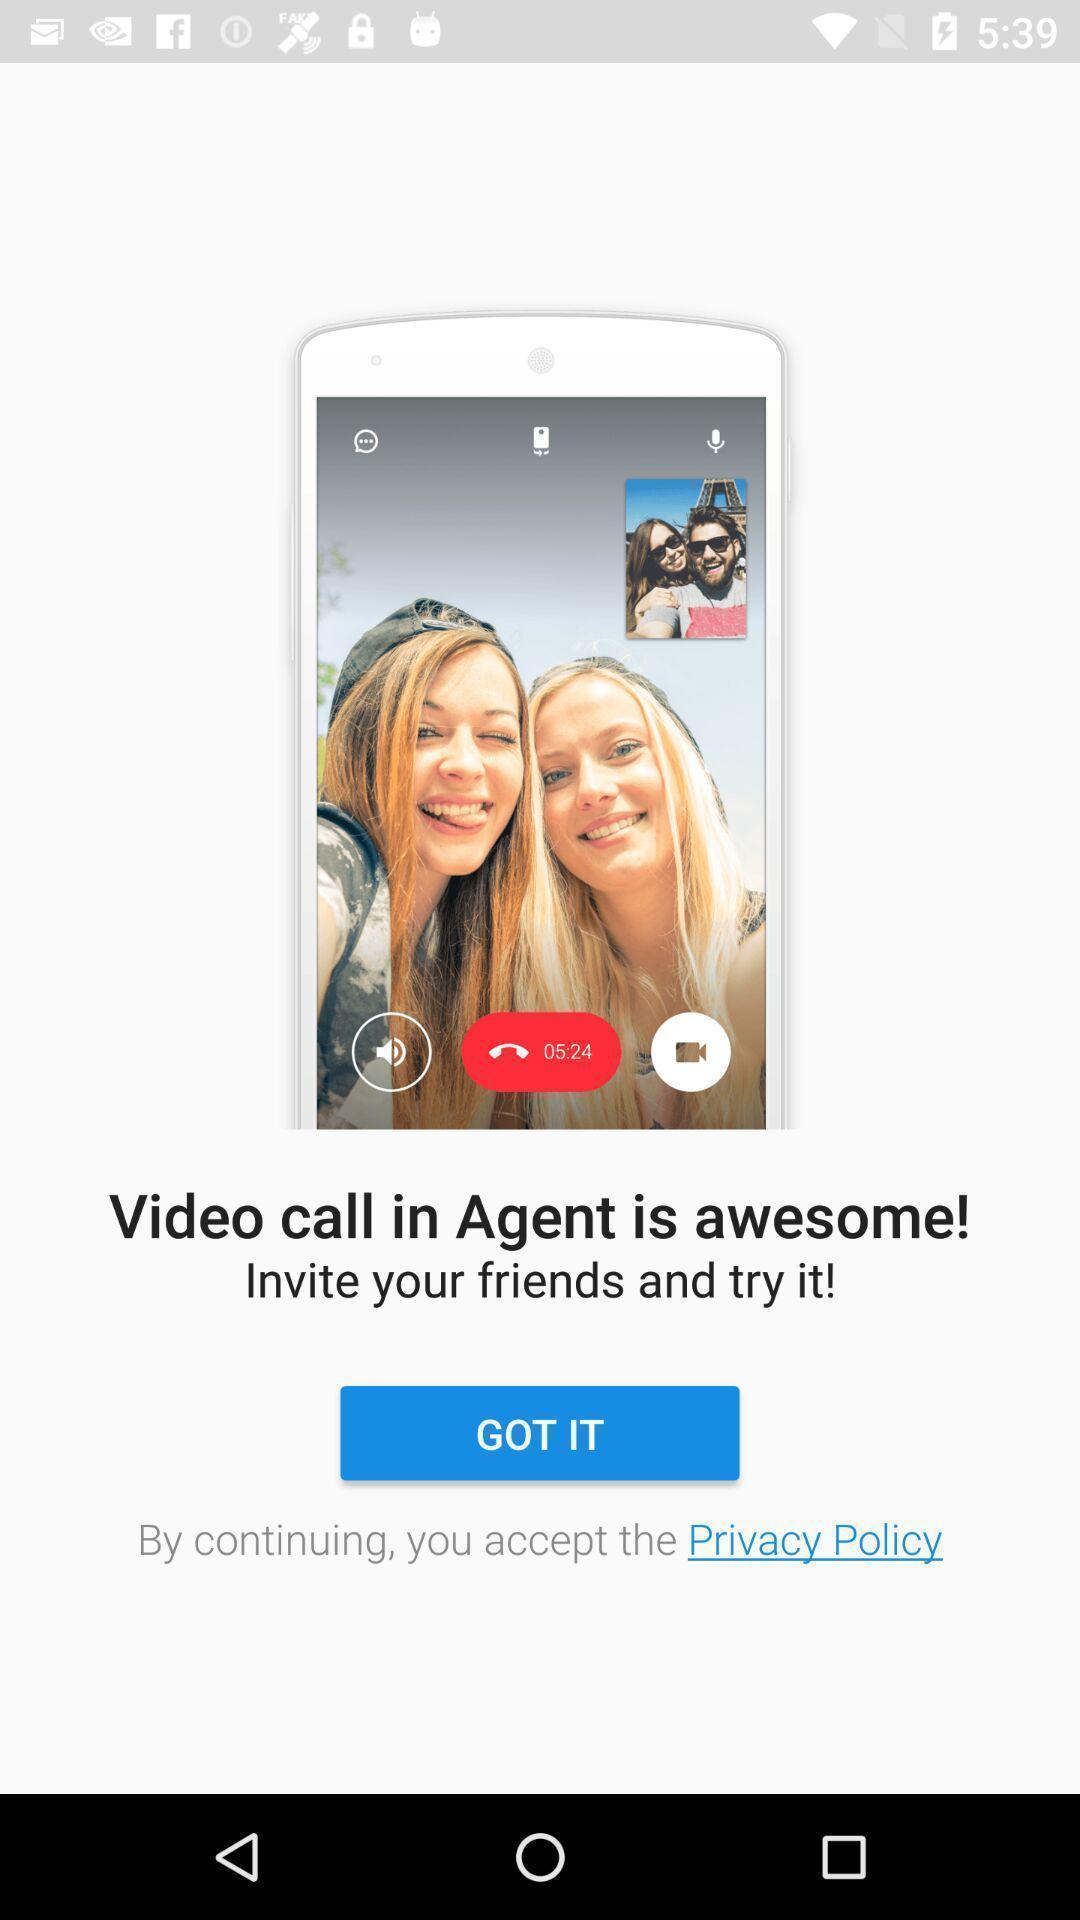Describe the content in this image. Welcome page of video calling application. 